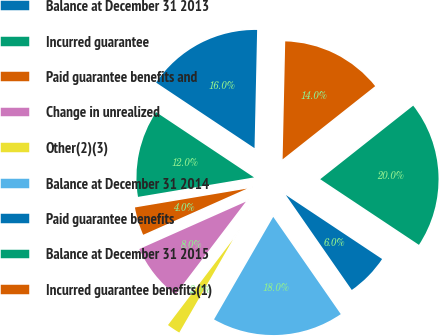<chart> <loc_0><loc_0><loc_500><loc_500><pie_chart><fcel>Balance at December 31 2013<fcel>Incurred guarantee<fcel>Paid guarantee benefits and<fcel>Change in unrealized<fcel>Other(2)(3)<fcel>Balance at December 31 2014<fcel>Paid guarantee benefits<fcel>Balance at December 31 2015<fcel>Incurred guarantee benefits(1)<nl><fcel>16.0%<fcel>12.0%<fcel>4.01%<fcel>8.0%<fcel>2.01%<fcel>17.99%<fcel>6.0%<fcel>19.99%<fcel>14.0%<nl></chart> 